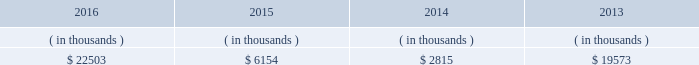Entergy louisiana , llc and subsidiaries management 2019s financial discussion and analysis entergy louisiana may refinance , redeem , or otherwise retire debt prior to maturity , to the extent market conditions and interest and distribution rates are favorable .
All debt and common and preferred membership interest issuances by entergy louisiana require prior regulatory approval .
Preferred membership interest and debt issuances are also subject to issuance tests set forth in its bond indentures and other agreements .
Entergy louisiana has sufficient capacity under these tests to meet its foreseeable capital needs .
Entergy louisiana 2019s receivables from the money pool were as follows as of december 31 for each of the following years. .
See note 4 to the financial statements for a description of the money pool .
Entergy louisiana has a credit facility in the amount of $ 350 million scheduled to expire in august 2021 .
The credit facility allows entergy louisiana to issue letters of credit against 50% ( 50 % ) of the borrowing capacity of the facility .
As of december 31 , 2016 , there were no cash borrowings and a $ 6.4 million letter of credit outstanding under the credit facility .
In addition , entergy louisiana is party to an uncommitted letter of credit facility as a means to post collateral to support its obligations under miso .
As of december 31 , 2016 , a $ 5.7 million letter of credit was outstanding under entergy louisiana 2019s uncommitted letter of credit facility .
See note 4 to the financial statements for additional discussion of the credit facilities .
The entergy louisiana nuclear fuel company variable interest entities have two separate credit facilities , one in the amount of $ 105 million and one in the amount of $ 85 million , both scheduled to expire in may 2019 .
As of december 31 , 2016 , $ 3.8 million of letters of credit were outstanding under the credit facility to support a like amount of commercial paper issued by the entergy louisiana waterford 3 nuclear fuel company variable interest entity and there were no cash borrowings outstanding under the credit facility for the entergy louisiana river bend nuclear fuel company variable interest entity .
See note 4 to the financial statements for additional discussion of the nuclear fuel company variable interest entity credit facility .
Entergy louisiana obtained authorizations from the ferc through october 2017 for the following : 2022 short-term borrowings not to exceed an aggregate amount of $ 450 million at any time outstanding ; 2022 long-term borrowings and security issuances ; and 2022 long-term borrowings by its nuclear fuel company variable interest entities .
See note 4 to the financial statements for further discussion of entergy louisiana 2019s short-term borrowing limits .
Hurricane isaac in june 2014 the lpsc voted to approve a series of orders which ( i ) quantified $ 290.8 million of hurricane isaac system restoration costs as prudently incurred ; ( ii ) determined $ 290 million as the level of storm reserves to be re-established ; ( iii ) authorized entergy louisiana to utilize louisiana act 55 financing for hurricane isaac system restoration costs ; and ( iv ) granted other requested relief associated with storm reserves and act 55 financing of hurricane isaac system restoration costs .
Entergy louisiana committed to pass on to customers a minimum of $ 30.8 million of customer benefits through annual customer credits of approximately $ 6.2 million for five years .
Approvals for the act 55 financings were obtained from the louisiana utilities restoration corporation and the louisiana state bond commission .
See note 2 to the financial statements for a discussion of the august 2014 issuance of bonds under act 55 of the louisiana legislature. .
What is the net change in entergy louisiana 2019s receivables from the money pool from 2015 to 2016? 
Computations: (22503 - 6154)
Answer: 16349.0. Entergy louisiana , llc and subsidiaries management 2019s financial discussion and analysis entergy louisiana may refinance , redeem , or otherwise retire debt prior to maturity , to the extent market conditions and interest and distribution rates are favorable .
All debt and common and preferred membership interest issuances by entergy louisiana require prior regulatory approval .
Preferred membership interest and debt issuances are also subject to issuance tests set forth in its bond indentures and other agreements .
Entergy louisiana has sufficient capacity under these tests to meet its foreseeable capital needs .
Entergy louisiana 2019s receivables from the money pool were as follows as of december 31 for each of the following years. .
See note 4 to the financial statements for a description of the money pool .
Entergy louisiana has a credit facility in the amount of $ 350 million scheduled to expire in august 2021 .
The credit facility allows entergy louisiana to issue letters of credit against 50% ( 50 % ) of the borrowing capacity of the facility .
As of december 31 , 2016 , there were no cash borrowings and a $ 6.4 million letter of credit outstanding under the credit facility .
In addition , entergy louisiana is party to an uncommitted letter of credit facility as a means to post collateral to support its obligations under miso .
As of december 31 , 2016 , a $ 5.7 million letter of credit was outstanding under entergy louisiana 2019s uncommitted letter of credit facility .
See note 4 to the financial statements for additional discussion of the credit facilities .
The entergy louisiana nuclear fuel company variable interest entities have two separate credit facilities , one in the amount of $ 105 million and one in the amount of $ 85 million , both scheduled to expire in may 2019 .
As of december 31 , 2016 , $ 3.8 million of letters of credit were outstanding under the credit facility to support a like amount of commercial paper issued by the entergy louisiana waterford 3 nuclear fuel company variable interest entity and there were no cash borrowings outstanding under the credit facility for the entergy louisiana river bend nuclear fuel company variable interest entity .
See note 4 to the financial statements for additional discussion of the nuclear fuel company variable interest entity credit facility .
Entergy louisiana obtained authorizations from the ferc through october 2017 for the following : 2022 short-term borrowings not to exceed an aggregate amount of $ 450 million at any time outstanding ; 2022 long-term borrowings and security issuances ; and 2022 long-term borrowings by its nuclear fuel company variable interest entities .
See note 4 to the financial statements for further discussion of entergy louisiana 2019s short-term borrowing limits .
Hurricane isaac in june 2014 the lpsc voted to approve a series of orders which ( i ) quantified $ 290.8 million of hurricane isaac system restoration costs as prudently incurred ; ( ii ) determined $ 290 million as the level of storm reserves to be re-established ; ( iii ) authorized entergy louisiana to utilize louisiana act 55 financing for hurricane isaac system restoration costs ; and ( iv ) granted other requested relief associated with storm reserves and act 55 financing of hurricane isaac system restoration costs .
Entergy louisiana committed to pass on to customers a minimum of $ 30.8 million of customer benefits through annual customer credits of approximately $ 6.2 million for five years .
Approvals for the act 55 financings were obtained from the louisiana utilities restoration corporation and the louisiana state bond commission .
See note 2 to the financial statements for a discussion of the august 2014 issuance of bonds under act 55 of the louisiana legislature. .
What is the net change in entergy louisiana 2019s receivables from the money pool from 2014 to 2015? 
Computations: (6154 - 2815)
Answer: 3339.0. 